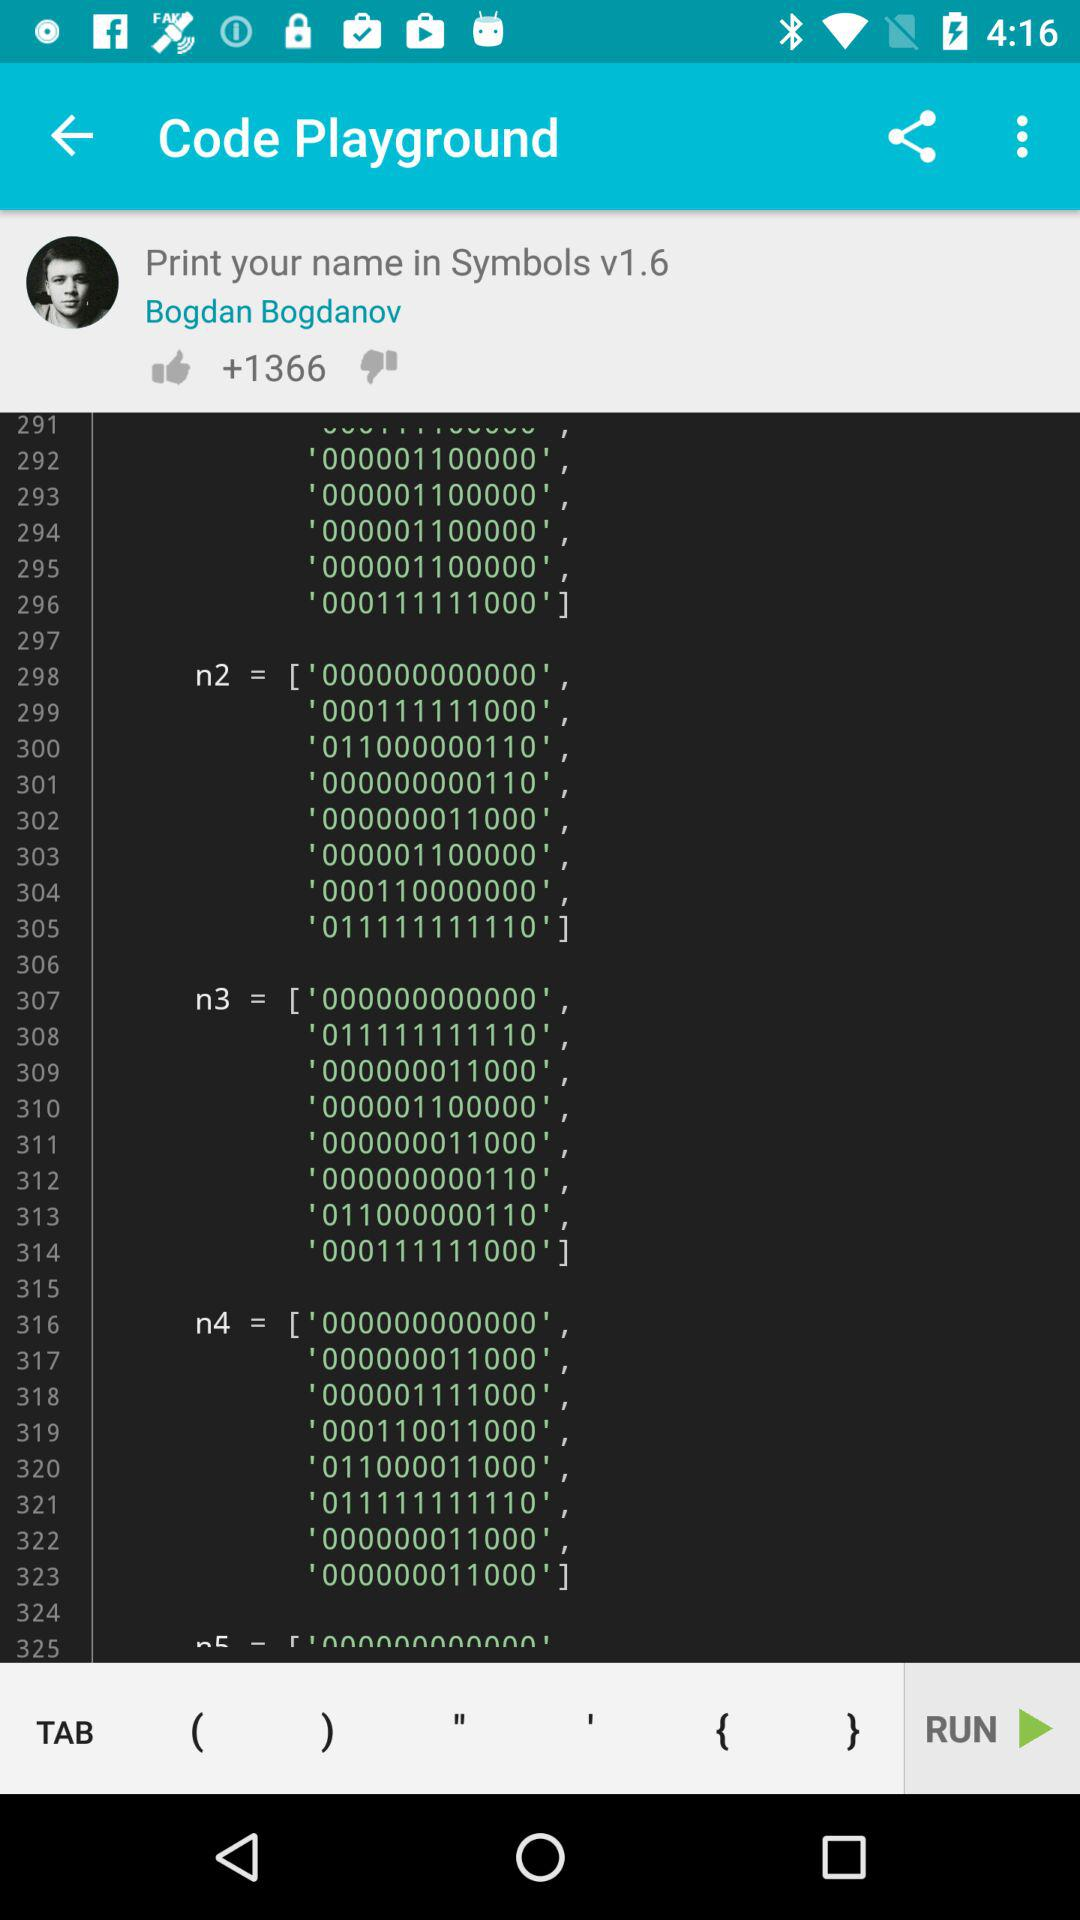How many likes are there? There are +1366 likes. 